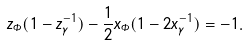Convert formula to latex. <formula><loc_0><loc_0><loc_500><loc_500>z _ { \Phi } ( 1 - z _ { \gamma } ^ { - 1 } ) - \frac { 1 } { 2 } x _ { \Phi } ( 1 - 2 x _ { \gamma } ^ { - 1 } ) = - 1 .</formula> 